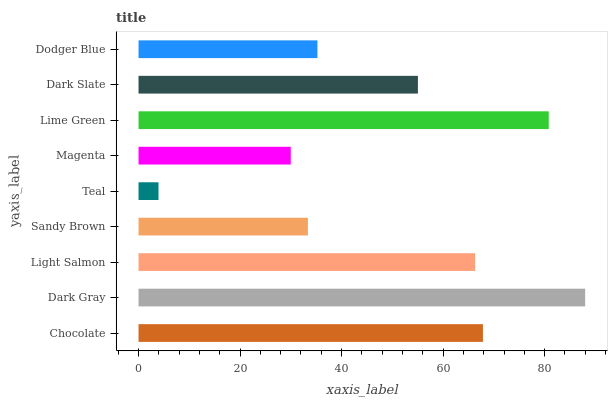Is Teal the minimum?
Answer yes or no. Yes. Is Dark Gray the maximum?
Answer yes or no. Yes. Is Light Salmon the minimum?
Answer yes or no. No. Is Light Salmon the maximum?
Answer yes or no. No. Is Dark Gray greater than Light Salmon?
Answer yes or no. Yes. Is Light Salmon less than Dark Gray?
Answer yes or no. Yes. Is Light Salmon greater than Dark Gray?
Answer yes or no. No. Is Dark Gray less than Light Salmon?
Answer yes or no. No. Is Dark Slate the high median?
Answer yes or no. Yes. Is Dark Slate the low median?
Answer yes or no. Yes. Is Teal the high median?
Answer yes or no. No. Is Lime Green the low median?
Answer yes or no. No. 